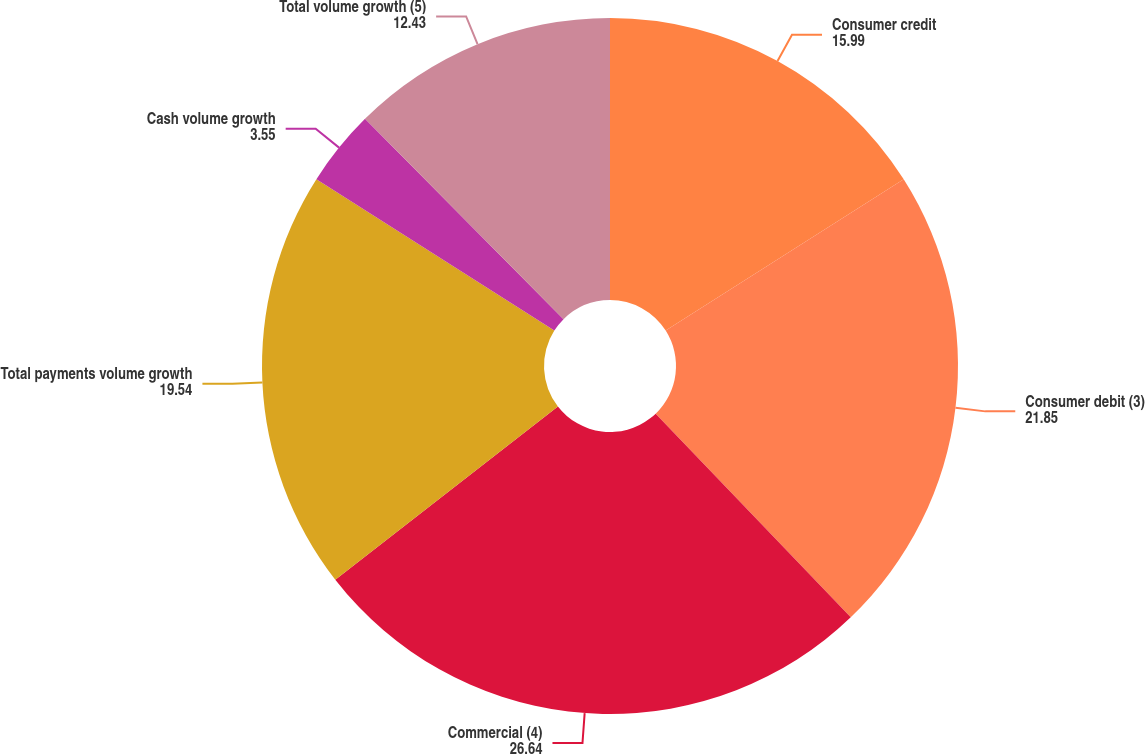Convert chart to OTSL. <chart><loc_0><loc_0><loc_500><loc_500><pie_chart><fcel>Consumer credit<fcel>Consumer debit (3)<fcel>Commercial (4)<fcel>Total payments volume growth<fcel>Cash volume growth<fcel>Total volume growth (5)<nl><fcel>15.99%<fcel>21.85%<fcel>26.64%<fcel>19.54%<fcel>3.55%<fcel>12.43%<nl></chart> 